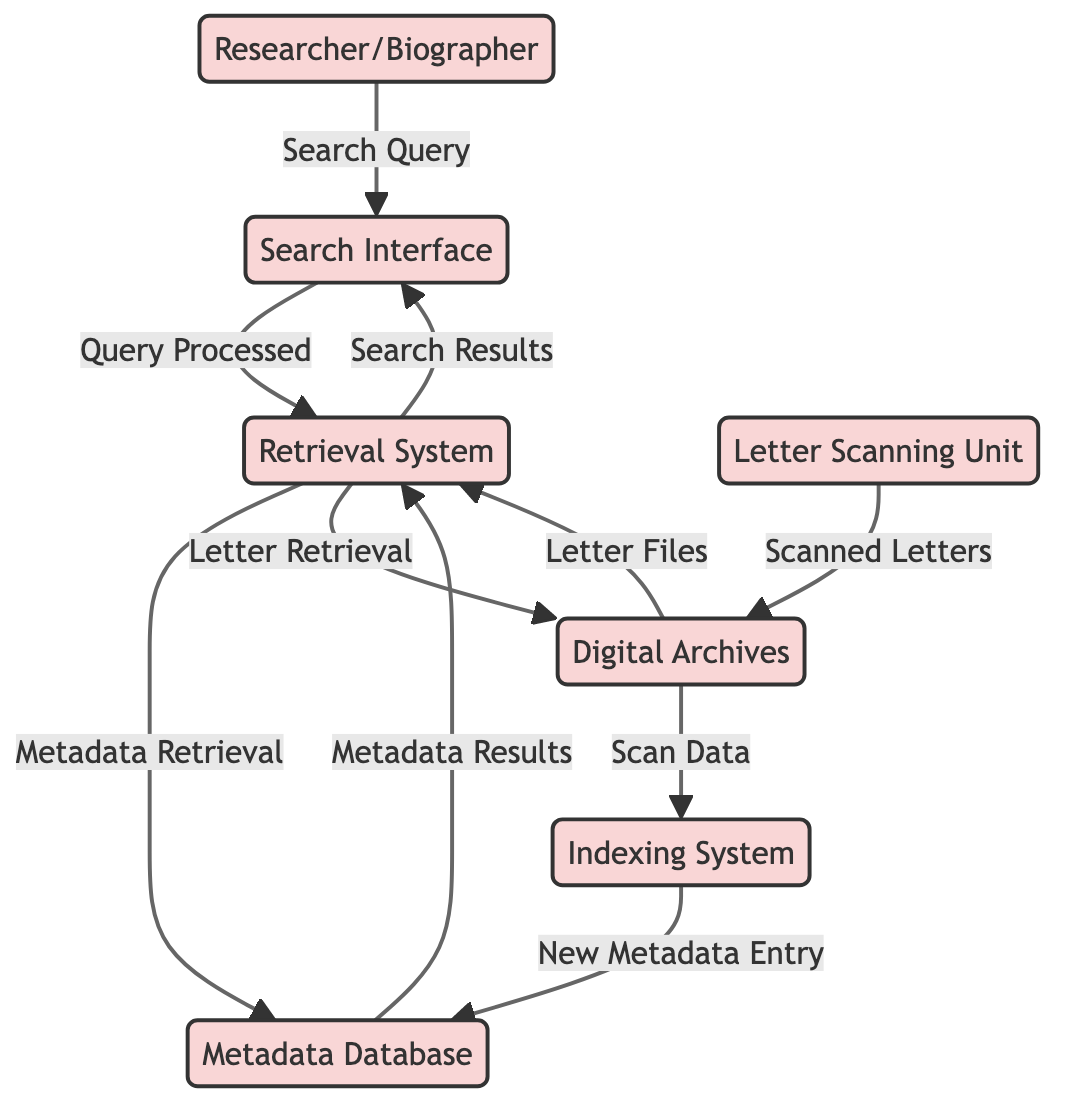What is the function of the Search Interface? The Search Interface allows the researcher to input search criteria and view search results, serving as the primary interaction point for users to access the system.
Answer: User interface How many main entities are present in the diagram? The diagram includes seven main entities representing different components of the Archival Access and Retrieval System, which are the Researcher/Biographer, Digital Archives, Metadata Database, Search Interface, Retrieval System, Letter Scanning Unit, and Indexing System.
Answer: Seven What is the source of the Scanned Letters data flow? The Scanned Letters data flow originates from the Letter Scanning Unit, which is responsible for digitizing physical personal letters before they are sent to the Digital Archives.
Answer: Letter Scanning Unit How does the Retrieval System obtain the metadata for the letters? The Retrieval System sends a request for relevant metadata to the Metadata Database, which processes the query and retrieves metadata for the letters that match the search criteria.
Answer: Metadata Database What flow occurs after the Search Query is processed? Following the processing of the Search Query in the Search Interface, the query is forwarded to the Retrieval System for further processing to find the relevant letters.
Answer: Retrieval System What is requested by the Retrieval System to access the digital files? The Retrieval System sends a request to the Digital Archives to access the digital files of the letters that match the user's search criteria, allowing for the retrieval of necessary documents.
Answer: Digital Archives Where does the new metadata enter the system? New metadata enters the Metadata Database from the Indexing System, which generates and uploads metadata for the recently scanned letters to keep the database updated.
Answer: Metadata Database What is the relationship between the Digital Archives and the Indexing System? The Digital Archives send scanned letter data to the Indexing System, which then processes this data to create new metadata entries for efficient search and retrieval later on.
Answer: Scanned letter data 